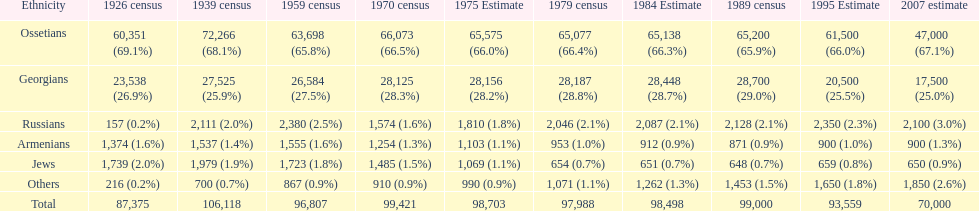In 1926, which population had the highest number of individuals? Ossetians. Help me parse the entirety of this table. {'header': ['Ethnicity', '1926 census', '1939 census', '1959 census', '1970 census', '1975 Estimate', '1979 census', '1984 Estimate', '1989 census', '1995 Estimate', '2007 estimate'], 'rows': [['Ossetians', '60,351 (69.1%)', '72,266 (68.1%)', '63,698 (65.8%)', '66,073 (66.5%)', '65,575 (66.0%)', '65,077 (66.4%)', '65,138 (66.3%)', '65,200 (65.9%)', '61,500 (66.0%)', '47,000 (67.1%)'], ['Georgians', '23,538 (26.9%)', '27,525 (25.9%)', '26,584 (27.5%)', '28,125 (28.3%)', '28,156 (28.2%)', '28,187 (28.8%)', '28,448 (28.7%)', '28,700 (29.0%)', '20,500 (25.5%)', '17,500 (25.0%)'], ['Russians', '157 (0.2%)', '2,111 (2.0%)', '2,380 (2.5%)', '1,574 (1.6%)', '1,810 (1.8%)', '2,046 (2.1%)', '2,087 (2.1%)', '2,128 (2.1%)', '2,350 (2.3%)', '2,100 (3.0%)'], ['Armenians', '1,374 (1.6%)', '1,537 (1.4%)', '1,555 (1.6%)', '1,254 (1.3%)', '1,103 (1.1%)', '953 (1.0%)', '912 (0.9%)', '871 (0.9%)', '900 (1.0%)', '900 (1.3%)'], ['Jews', '1,739 (2.0%)', '1,979 (1.9%)', '1,723 (1.8%)', '1,485 (1.5%)', '1,069 (1.1%)', '654 (0.7%)', '651 (0.7%)', '648 (0.7%)', '659 (0.8%)', '650 (0.9%)'], ['Others', '216 (0.2%)', '700 (0.7%)', '867 (0.9%)', '910 (0.9%)', '990 (0.9%)', '1,071 (1.1%)', '1,262 (1.3%)', '1,453 (1.5%)', '1,650 (1.8%)', '1,850 (2.6%)'], ['Total', '87,375', '106,118', '96,807', '99,421', '98,703', '97,988', '98,498', '99,000', '93,559', '70,000']]} 